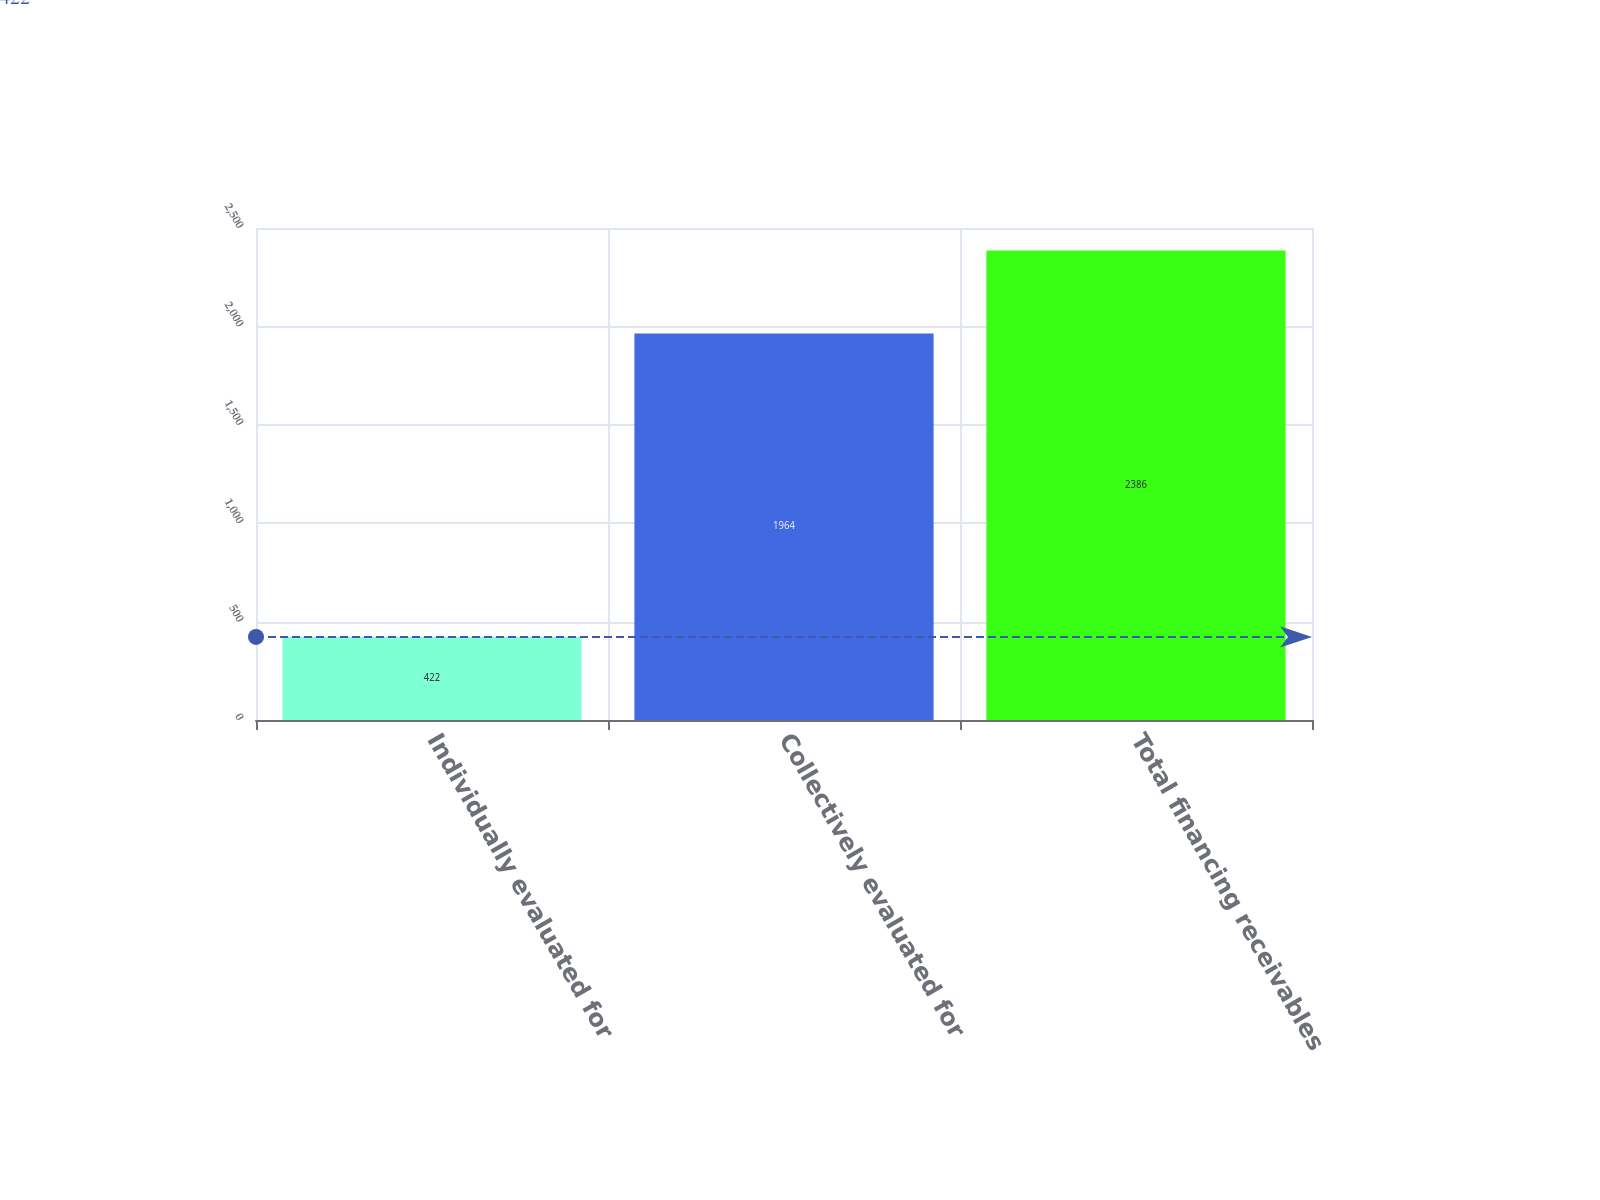Convert chart to OTSL. <chart><loc_0><loc_0><loc_500><loc_500><bar_chart><fcel>Individually evaluated for<fcel>Collectively evaluated for<fcel>Total financing receivables<nl><fcel>422<fcel>1964<fcel>2386<nl></chart> 